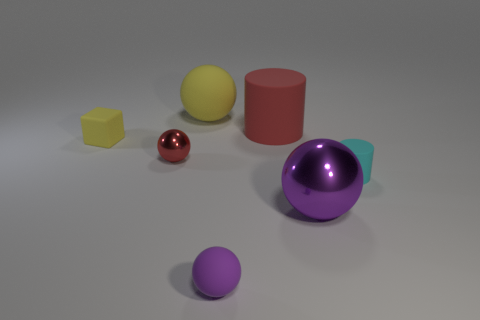Subtract all yellow rubber spheres. How many spheres are left? 3 Subtract all purple balls. How many balls are left? 2 Subtract 1 cylinders. How many cylinders are left? 1 Subtract all yellow cylinders. How many red spheres are left? 1 Add 2 tiny cyan cylinders. How many objects exist? 9 Subtract all cylinders. How many objects are left? 5 Add 7 big purple things. How many big purple things are left? 8 Add 6 large green rubber balls. How many large green rubber balls exist? 6 Subtract 0 yellow cylinders. How many objects are left? 7 Subtract all red cubes. Subtract all yellow cylinders. How many cubes are left? 1 